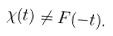Convert formula to latex. <formula><loc_0><loc_0><loc_500><loc_500>\chi ( t ) \neq F ( - t ) .</formula> 